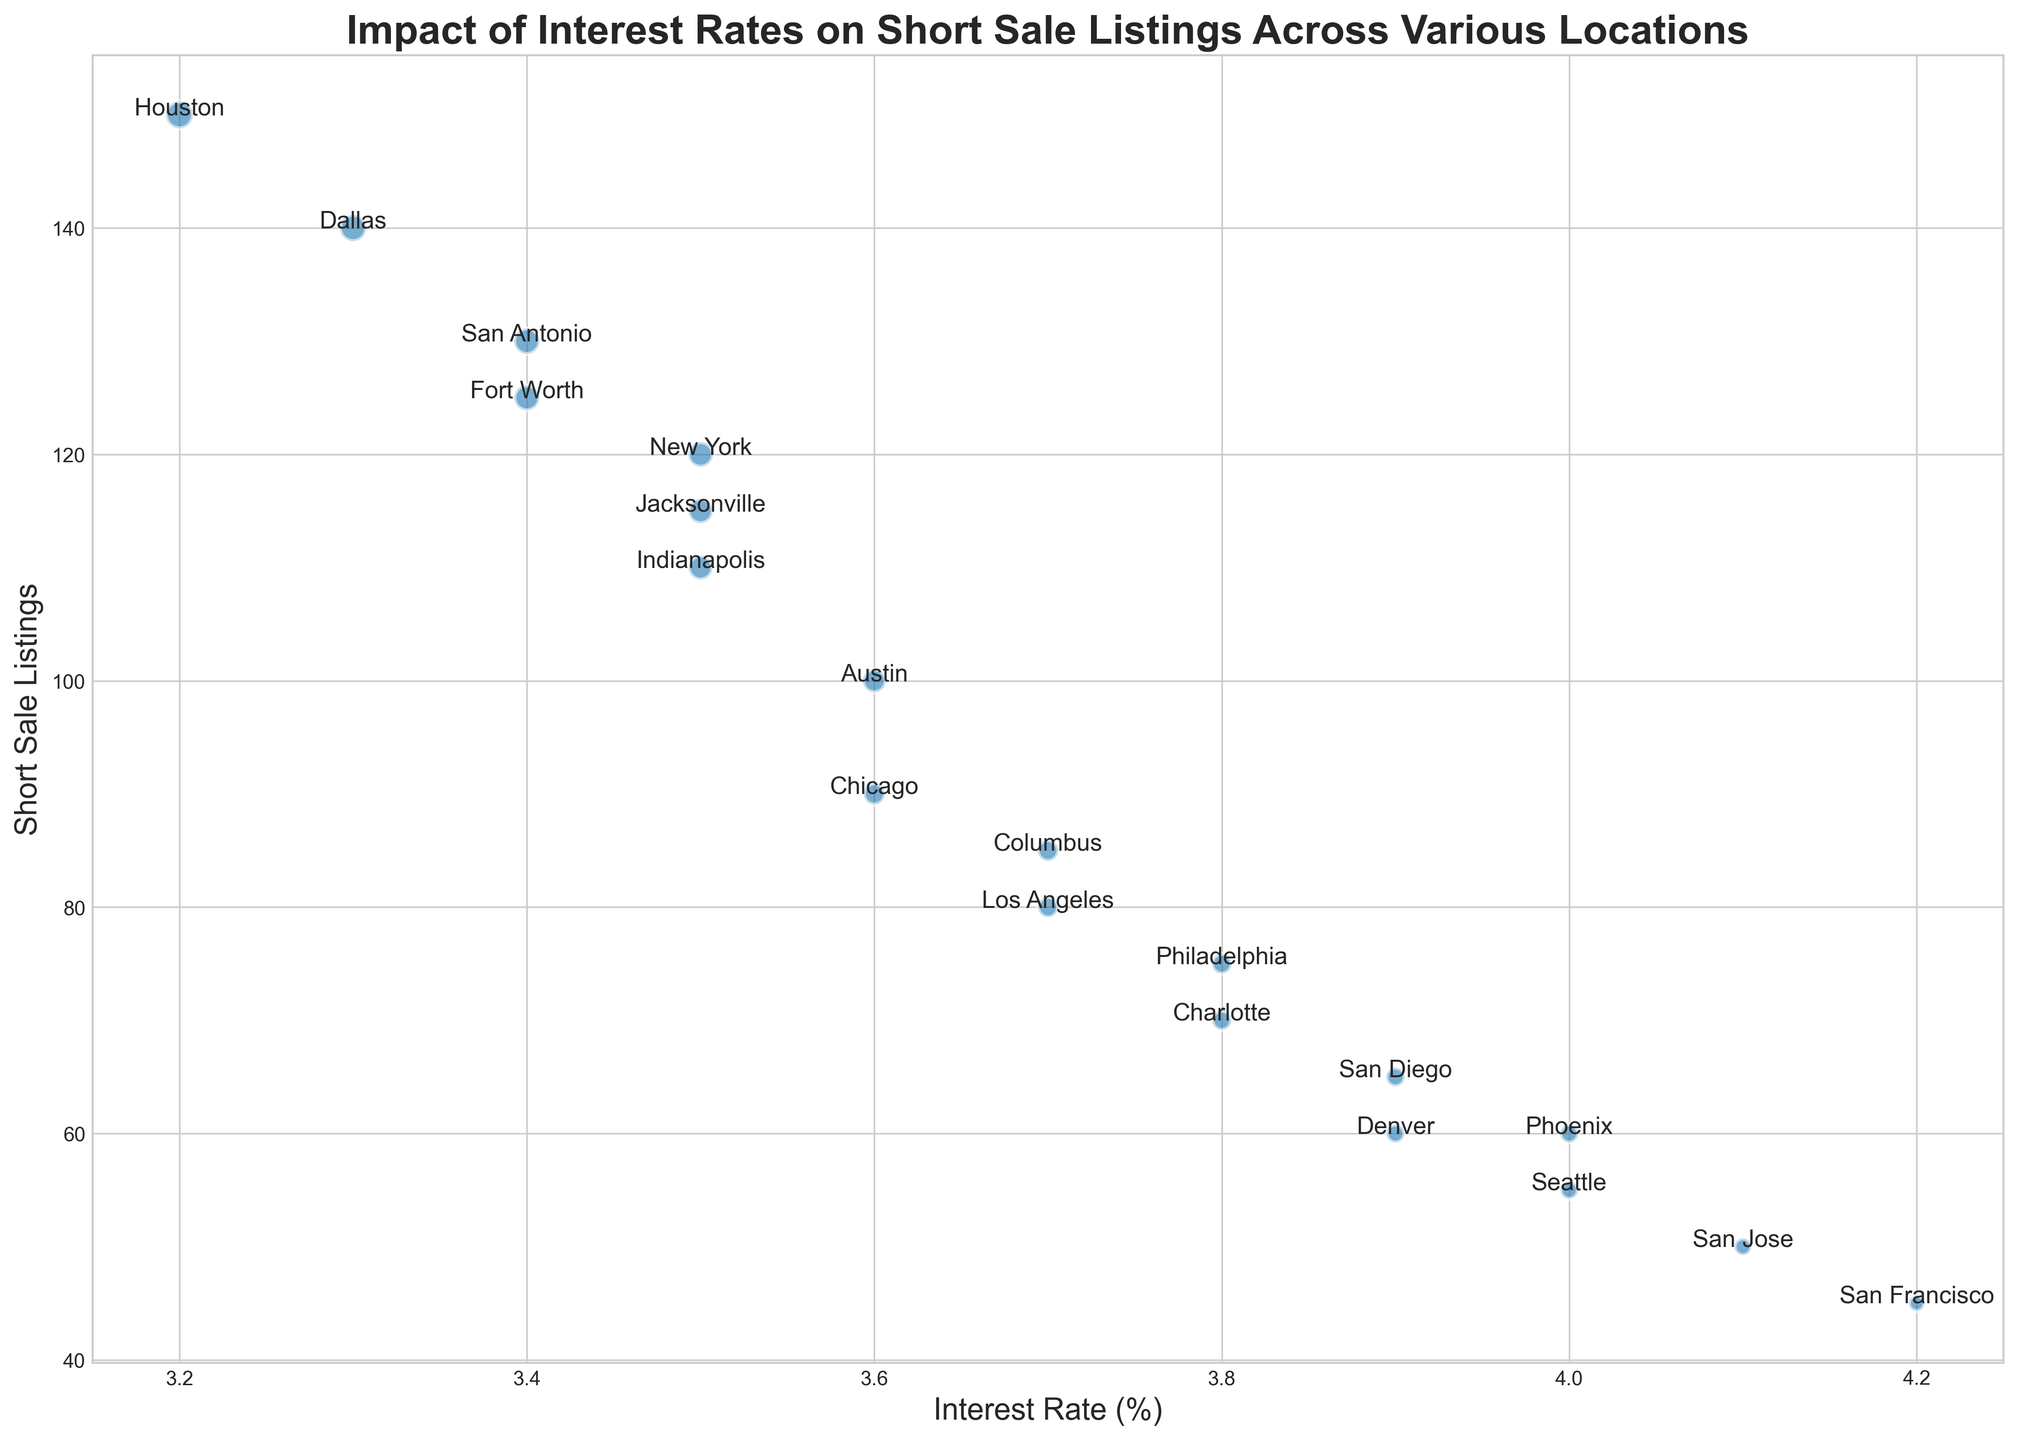What's the relationship between interest rates and short sale listings for New York and Philadelphia? First, identify the interest rates and short sale listings for New York and Philadelphia. New York has an interest rate of 3.5% and 120 short sale listings. Philadelphia has an interest rate of 3.8% and 75 short sale listings. New York has a lower interest rate with more short sale listings than Philadelphia.
Answer: New York has lower interest rates and more short sale listings than Philadelphia Which city has the highest number of short sale listings? Look for the city with the highest value in the 'Short Sale Listings' column. Among the listed cities, Houston has the highest number with 150 short sale listings.
Answer: Houston Is there a city with an interest rate higher than 4.0%? If yes, which one and how many short sale listings does it have? Check the Interest Rate column for values higher than 4.0%. Both San Jose and San Francisco have interest rates higher than 4.0%. San Jose has 50 short sale listings, and San Francisco has 45 short sale listings.
Answer: San Jose (50), San Francisco (45) Which location has the smallest bubble size in the chart, and what does it represent? Look for the smallest bubble in the chart, which corresponds to San Francisco with a bubble size of 60. The bubble size represents the magnitude or prominence of the impact being measured, typically indicating a smaller volume or scale.
Answer: San Francisco, smaller impact Compare the short sale listings between the cities with the lowest and highest interest rates. What do you observe? Houston has the lowest interest rate at 3.2% with 150 short sale listings, while San Francisco has the highest interest rate at 4.2% with 45 short sale listings. The city with the lowest interest rate has significantly more short sale listings than the city with the highest rate.
Answer: Houston (3.2%, 150) vs. San Francisco (4.2%, 45) Which cities have exactly 3.4% interest rate, and how do their short sale listings compare? Identify cities with an interest rate of 3.4%. San Antonio has 130 short sale listings, and Fort Worth has 125 short sale listings. San Antonio has slightly more short sale listings than Fort Worth.
Answer: San Antonio (130), Fort Worth (125) What is the average interest rate across all listed locations? Sum all the interest rates and divide by the number of locations. The total sum of interest rates is 71.5 across 19 locations. Calculate the average: 71.5 / 19 ≈ 3.76.
Answer: ~3.76% What trend can you observe between bubble size and the number of short sale listings? Generally, bubble size increases with the number of short sale listings. For example, Houston with 150 short sale listings has the largest bubble size of 180. Conversely, San Francisco with 45 short sale listings has the smallest bubble size of 60.
Answer: Larger bubbles often indicate more short sale listings What is the median number of short sale listings? List all short sale listings in ascending order, then find the middle value. Ordered list: 45, 50, 55, 60, 60, 65, 70, 75, 80, 85, 90, 100, 110, 115, 120, 125, 130, 140, 150. The middle (10th) value is 85.
Answer: 85 